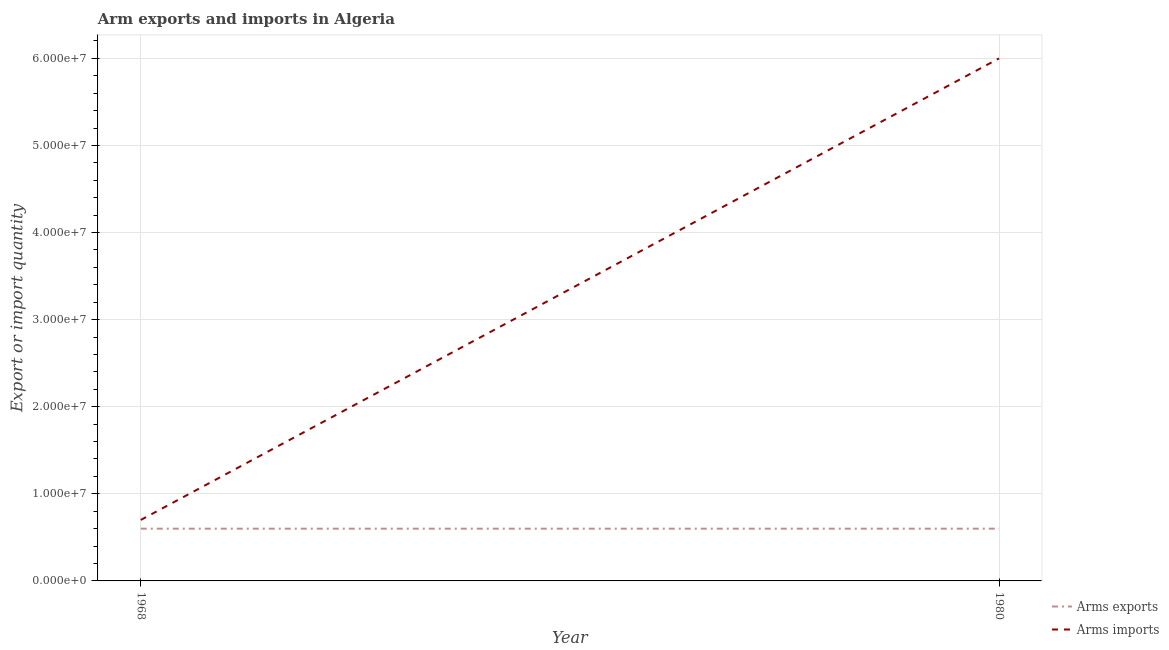How many different coloured lines are there?
Provide a short and direct response. 2. Does the line corresponding to arms exports intersect with the line corresponding to arms imports?
Ensure brevity in your answer.  No. Is the number of lines equal to the number of legend labels?
Your answer should be compact. Yes. What is the arms imports in 1980?
Your answer should be very brief. 6.00e+07. Across all years, what is the maximum arms imports?
Provide a succinct answer. 6.00e+07. Across all years, what is the minimum arms exports?
Ensure brevity in your answer.  6.00e+06. In which year was the arms exports maximum?
Your answer should be very brief. 1968. In which year was the arms exports minimum?
Give a very brief answer. 1968. What is the total arms imports in the graph?
Your answer should be very brief. 6.70e+07. What is the difference between the arms imports in 1968 and that in 1980?
Offer a terse response. -5.30e+07. What is the difference between the arms exports in 1980 and the arms imports in 1968?
Your answer should be compact. -1.00e+06. What is the average arms exports per year?
Your response must be concise. 6.00e+06. In the year 1968, what is the difference between the arms imports and arms exports?
Ensure brevity in your answer.  1.00e+06. What is the ratio of the arms imports in 1968 to that in 1980?
Offer a very short reply. 0.12. In how many years, is the arms imports greater than the average arms imports taken over all years?
Provide a short and direct response. 1. Does the arms imports monotonically increase over the years?
Keep it short and to the point. Yes. Is the arms exports strictly less than the arms imports over the years?
Make the answer very short. Yes. How many lines are there?
Your answer should be compact. 2. How many years are there in the graph?
Provide a succinct answer. 2. Are the values on the major ticks of Y-axis written in scientific E-notation?
Give a very brief answer. Yes. Does the graph contain any zero values?
Offer a terse response. No. Where does the legend appear in the graph?
Ensure brevity in your answer.  Bottom right. How are the legend labels stacked?
Make the answer very short. Vertical. What is the title of the graph?
Offer a terse response. Arm exports and imports in Algeria. What is the label or title of the Y-axis?
Keep it short and to the point. Export or import quantity. What is the Export or import quantity in Arms exports in 1968?
Give a very brief answer. 6.00e+06. What is the Export or import quantity in Arms exports in 1980?
Ensure brevity in your answer.  6.00e+06. What is the Export or import quantity in Arms imports in 1980?
Your answer should be very brief. 6.00e+07. Across all years, what is the maximum Export or import quantity in Arms imports?
Give a very brief answer. 6.00e+07. Across all years, what is the minimum Export or import quantity of Arms exports?
Your answer should be very brief. 6.00e+06. Across all years, what is the minimum Export or import quantity in Arms imports?
Your response must be concise. 7.00e+06. What is the total Export or import quantity of Arms imports in the graph?
Your response must be concise. 6.70e+07. What is the difference between the Export or import quantity in Arms imports in 1968 and that in 1980?
Ensure brevity in your answer.  -5.30e+07. What is the difference between the Export or import quantity in Arms exports in 1968 and the Export or import quantity in Arms imports in 1980?
Ensure brevity in your answer.  -5.40e+07. What is the average Export or import quantity of Arms imports per year?
Offer a very short reply. 3.35e+07. In the year 1968, what is the difference between the Export or import quantity of Arms exports and Export or import quantity of Arms imports?
Keep it short and to the point. -1.00e+06. In the year 1980, what is the difference between the Export or import quantity of Arms exports and Export or import quantity of Arms imports?
Offer a terse response. -5.40e+07. What is the ratio of the Export or import quantity of Arms imports in 1968 to that in 1980?
Keep it short and to the point. 0.12. What is the difference between the highest and the second highest Export or import quantity of Arms imports?
Your answer should be very brief. 5.30e+07. What is the difference between the highest and the lowest Export or import quantity of Arms exports?
Keep it short and to the point. 0. What is the difference between the highest and the lowest Export or import quantity of Arms imports?
Offer a terse response. 5.30e+07. 